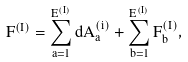Convert formula to latex. <formula><loc_0><loc_0><loc_500><loc_500>F ^ { ( I ) } = \sum _ { a = 1 } ^ { E ^ { ( I ) } } d A ^ { ( i ) } _ { a } + \sum _ { b = 1 } ^ { E ^ { ( I ) } } F ^ { ( I ) } _ { b } ,</formula> 